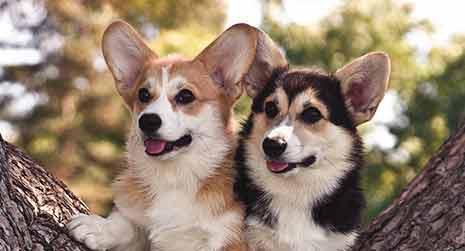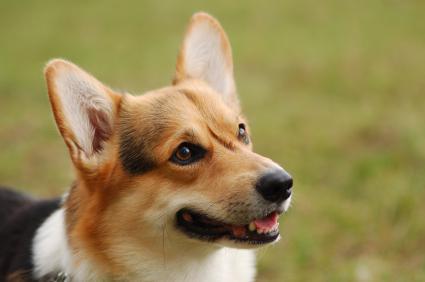The first image is the image on the left, the second image is the image on the right. Considering the images on both sides, is "The entire dog is visible in the image on the left." valid? Answer yes or no. No. 